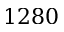Convert formula to latex. <formula><loc_0><loc_0><loc_500><loc_500>1 2 8 0</formula> 